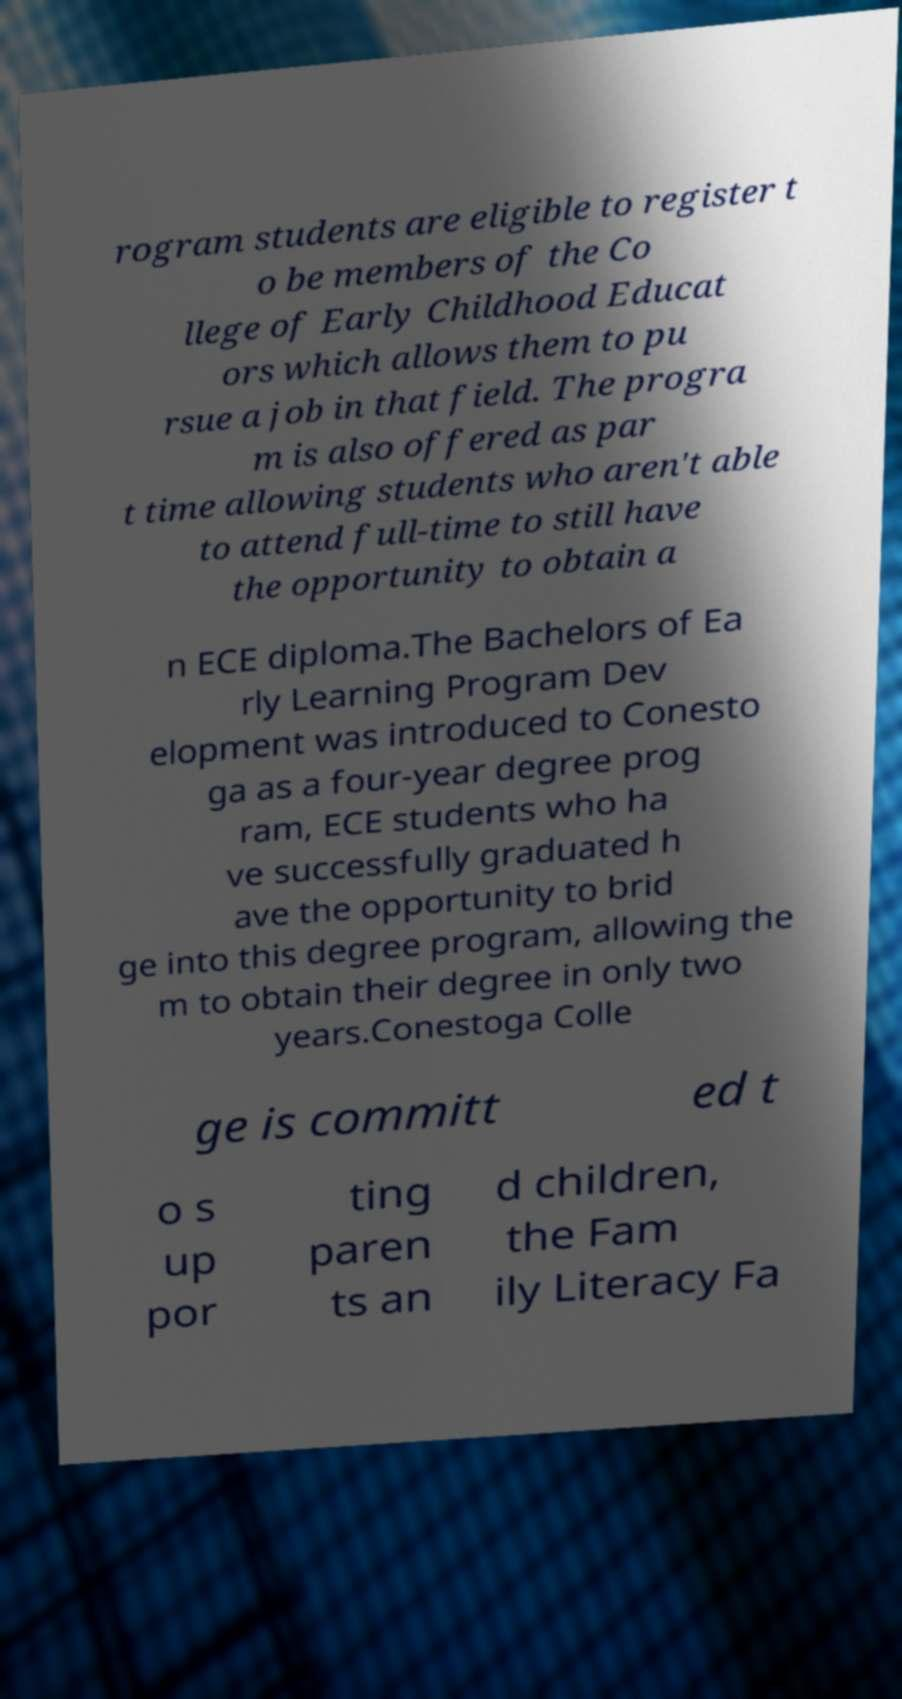Can you read and provide the text displayed in the image?This photo seems to have some interesting text. Can you extract and type it out for me? rogram students are eligible to register t o be members of the Co llege of Early Childhood Educat ors which allows them to pu rsue a job in that field. The progra m is also offered as par t time allowing students who aren't able to attend full-time to still have the opportunity to obtain a n ECE diploma.The Bachelors of Ea rly Learning Program Dev elopment was introduced to Conesto ga as a four-year degree prog ram, ECE students who ha ve successfully graduated h ave the opportunity to brid ge into this degree program, allowing the m to obtain their degree in only two years.Conestoga Colle ge is committ ed t o s up por ting paren ts an d children, the Fam ily Literacy Fa 